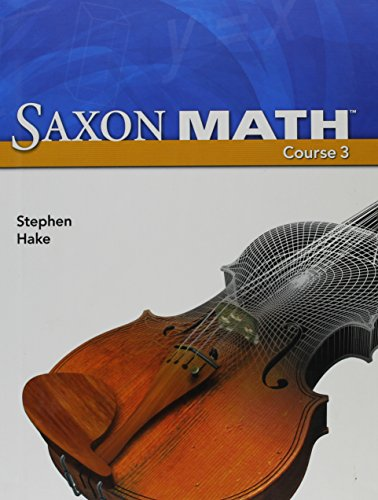What is the title of this book? The full title of the book as displayed on the cover is 'Saxon Math Course 3', a 2007 edition designed for student use. 